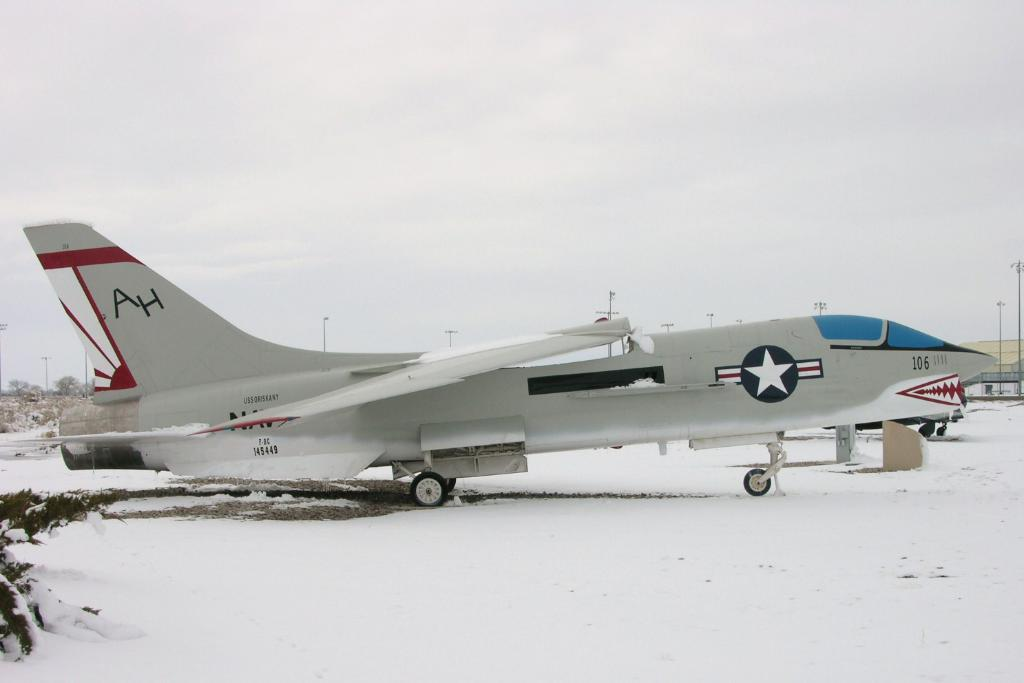<image>
Share a concise interpretation of the image provided. A military plane has the letters "AH" written on the tail. 